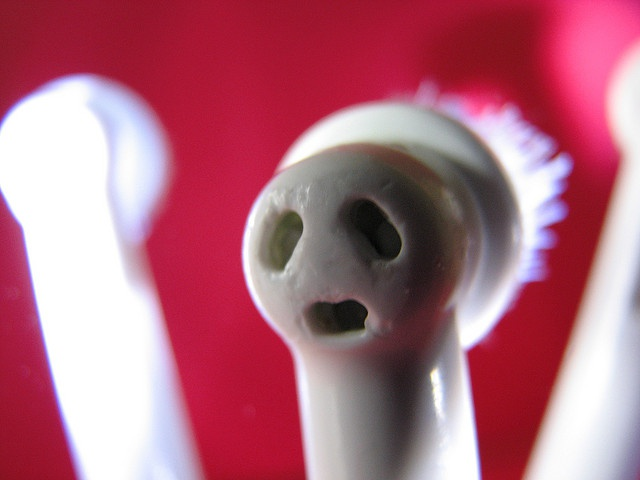Describe the objects in this image and their specific colors. I can see toothbrush in brown, lavender, gray, darkgray, and black tones, toothbrush in brown, white, pink, and violet tones, and toothbrush in brown, white, lightpink, and darkgray tones in this image. 